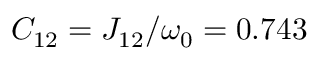<formula> <loc_0><loc_0><loc_500><loc_500>C _ { 1 2 } = J _ { 1 2 } / \omega _ { 0 } = 0 . 7 4 3</formula> 